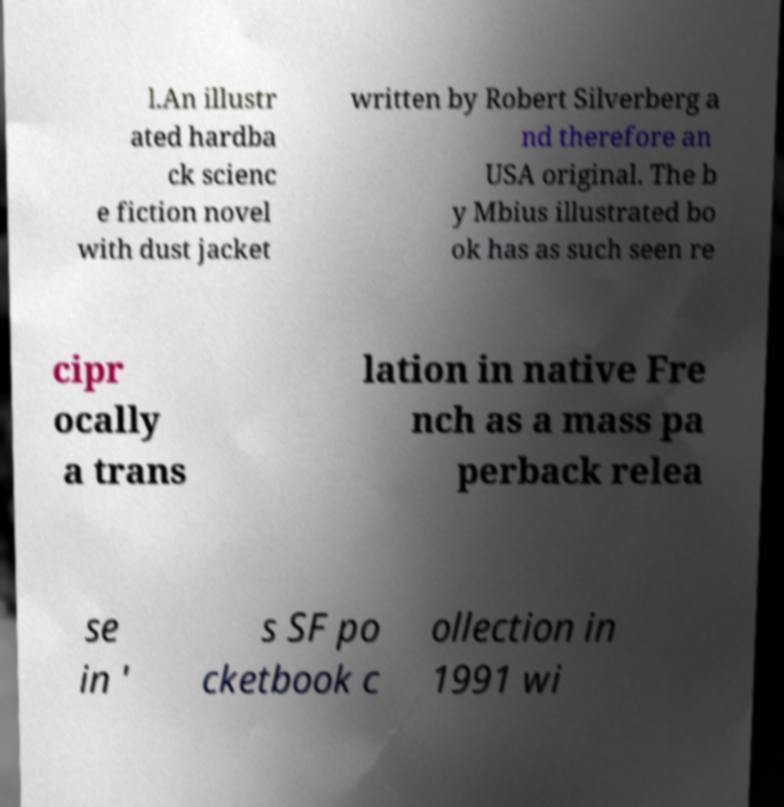For documentation purposes, I need the text within this image transcribed. Could you provide that? l.An illustr ated hardba ck scienc e fiction novel with dust jacket written by Robert Silverberg a nd therefore an USA original. The b y Mbius illustrated bo ok has as such seen re cipr ocally a trans lation in native Fre nch as a mass pa perback relea se in ' s SF po cketbook c ollection in 1991 wi 